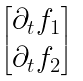Convert formula to latex. <formula><loc_0><loc_0><loc_500><loc_500>\begin{bmatrix} \partial _ { t } f _ { 1 } \\ \partial _ { t } f _ { 2 } \end{bmatrix}</formula> 